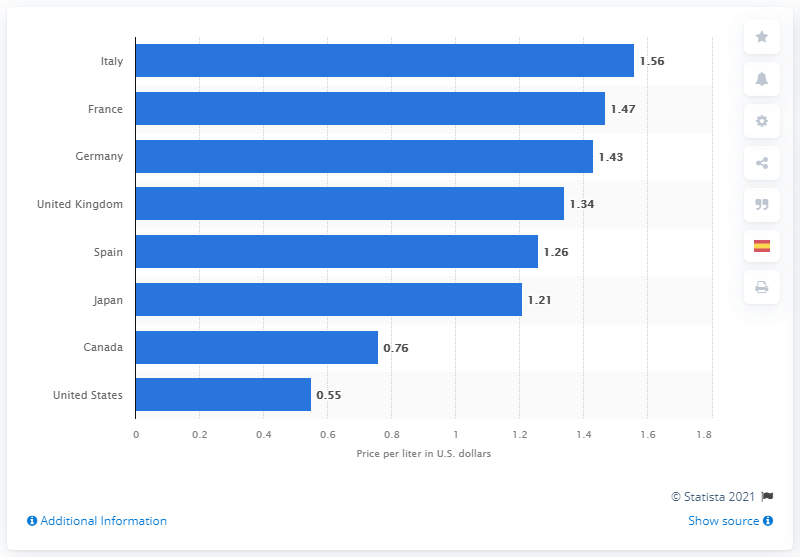Highlight a few significant elements in this photo. The highest price per liter of fuel in the United States in June 2020 was 1.56 dollars. In June 2020, the price per liter of gasoline in the United States was 0.55 dollars. 